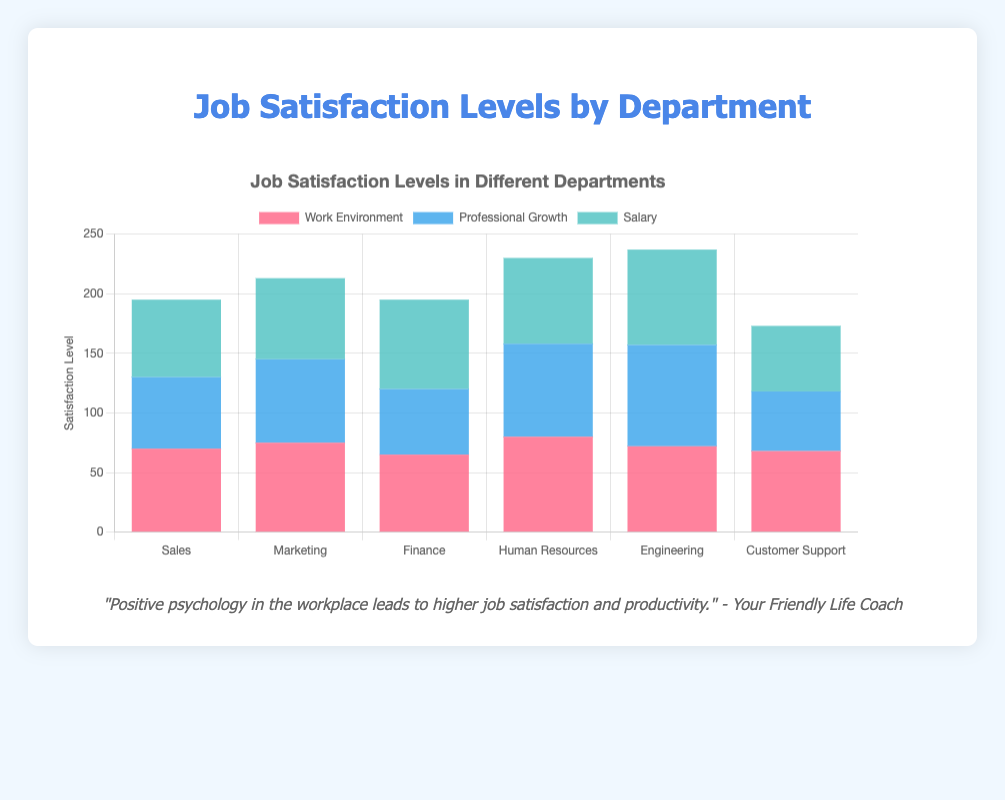What's the overall satisfaction level for the Sales department? To find the overall satisfaction level, sum up the satisfaction levels of Work Environment, Professional Growth, and Salary. For Sales, it's 70 (Work Environment) + 60 (Professional Growth) + 65 (Salary) = 195.
Answer: 195 Which department has the highest satisfaction level in terms of Work Environment? Look at the Work Environment satisfaction levels for all departments. Human Resources has the highest score of 80.
Answer: Human Resources In which department is there the smallest difference between the satisfaction levels of Work Environment and Professional Growth? Calculate the differences for all departments: Sales (70-60=10), Marketing (75-70=5), Finance (65-55=10), Human Resources (80-78=2), Engineering (72-85=13), Customer Support (68-50=18). Human Resources has the smallest difference of 2.
Answer: Human Resources Compare the satisfaction levels of Engineering and Finance in terms of Salary. Which one is higher? Engineering has a Salary satisfaction level of 80, while Finance has 75. Therefore, Engineering is higher.
Answer: Engineering What is the total satisfaction level across all departments for Professional Growth? Sum up the Professional Growth satisfaction levels: Sales (60) + Marketing (70) + Finance (55) + Human Resources (78) + Engineering (85) + Customer Support (50). The total is 398.
Answer: 398 Which department has the highest satisfaction level in Salary? Look at the Salary satisfaction levels for all departments. Engineering has the highest score of 80.
Answer: Engineering What's the difference in overall satisfaction between Human Resources and Customer Support? Calculate the overall satisfaction for both: Human Resources = 80 (Work Environment) + 78 (Professional Growth) + 72 (Salary) = 230, Customer Support = 68 (Work Environment) + 50 (Professional Growth) + 55 (Salary) = 173. The difference is 230 - 173 = 57.
Answer: 57 What is the average satisfaction level for Professional Growth in all departments? Sum up the Professional Growth satisfaction levels and divide by the number of departments: (60 + 70 + 55 + 78 + 85 + 50) / 6 = 398 / 6 ≈ 66.33.
Answer: 66.33 Which department has the lowest satisfaction level in terms of Professional Growth and what is that level? Look at the Professional Growth satisfaction levels for all departments. Customer Support has the lowest score of 50.
Answer: Customer Support Is there any department where the satisfaction level in Work Environment is less than 70? If yes, which one(s)? Look at the Work Environment satisfaction levels: Finance (65). Thus, Finance has a Work Environment satisfaction level less than 70.
Answer: Finance 